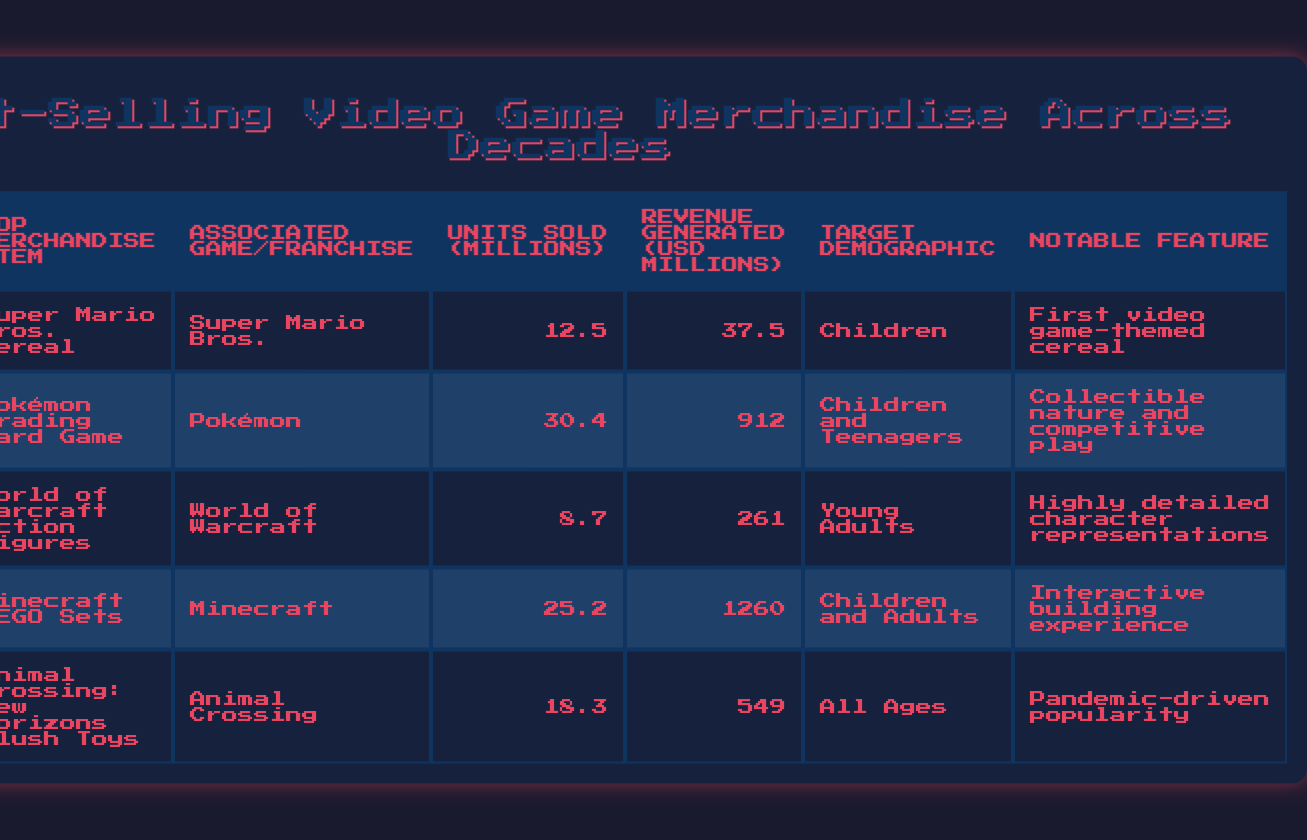What was the top merchandise item of the 1990s? From the table, the row corresponding to the 1990s shows that the top merchandise item was the Pokémon Trading Card Game.
Answer: Pokémon Trading Card Game How many units were sold of the Super Mario Bros. Cereal? According to the table, the Super Mario Bros. Cereal, which was popular in the 1980s, sold 12.5 million units.
Answer: 12.5 million Which decade had the highest revenue generated from merchandise? Looking at the revenue generated for each decade, the 2010s had the highest value of 1260 million USD from Minecraft LEGO Sets.
Answer: 2010s Is it true that World of Warcraft Action Figures had units sold greater than 10 million? The table indicates that World of Warcraft Action Figures sold 8.7 million units, which is less than 10 million. Therefore, the statement is false.
Answer: No What was the difference in revenue generated between the Pokémon Trading Card Game and Minecraft LEGO Sets? The revenue for the Pokémon Trading Card Game is 912 million USD and for Minecraft LEGO Sets is 1260 million USD. To find the difference, subtract 912 from 1260, which equals 348 million USD.
Answer: 348 million USD Considering all decades, what is the total number of units sold for all merchandise items? To find the total units sold, add the units sold for each item: 12.5 (1980s) + 30.4 (1990s) + 8.7 (2000s) + 25.2 (2010s) + 18.3 (2020s) = 95.1 million units in total.
Answer: 95.1 million Which merchandise item had the highest target demographic range? The Animal Crossing: New Horizons Plush Toys are targeted at all ages, which encompasses a broader demographic compared to the others.
Answer: Animal Crossing: New Horizons Plush Toys What is the average number of units sold by merchandise across the decades? To calculate the average, first sum up the units sold: 12.5 + 30.4 + 8.7 + 25.2 + 18.3 = 95.1 million. Then divide by the number of items (5), giving an average of 19.02 million units sold per item.
Answer: 19.02 million units Which associated game/franchise has the highest number of units sold for its merchandise? By examining the units sold, the Pokémon franchise has 30.4 million units sold, which is the highest in this dataset.
Answer: Pokémon 